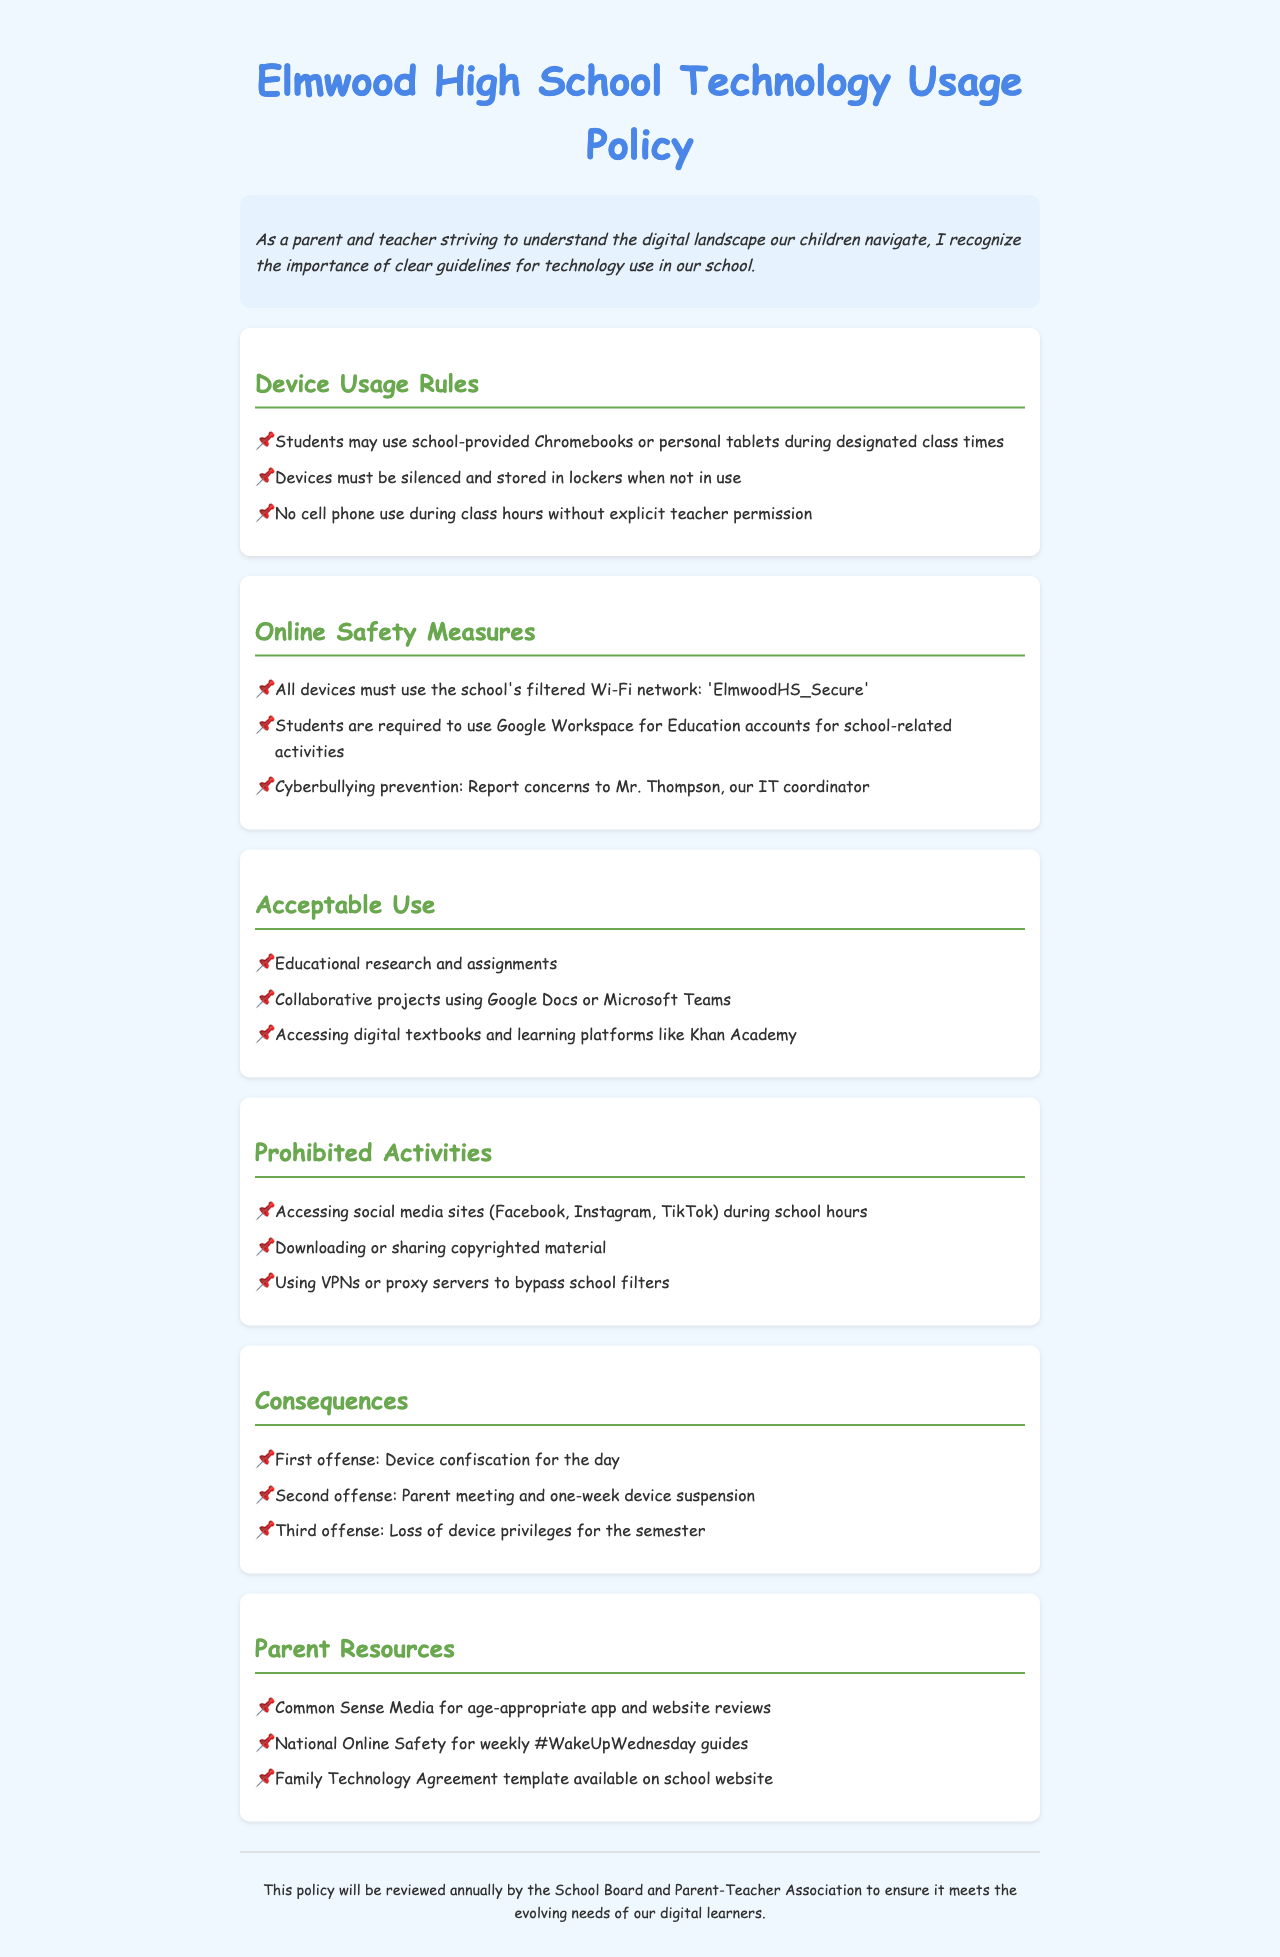What devices can students use during class? The document states that students may use school-provided Chromebooks or personal tablets during designated class times.
Answer: Chromebooks or personal tablets What must students do with their devices when not in use? According to the document, devices must be silenced and stored in lockers when not in use.
Answer: Silenced and stored in lockers How should students connect to the internet? The policy requires all devices to use the school's filtered Wi-Fi network named 'ElmwoodHS_Secure'.
Answer: ElmwoodHS_Secure What action should be taken for cyberbullying concerns? The document indicates that students must report concerns to Mr. Thompson, our IT coordinator.
Answer: Report to Mr. Thompson What is the consequence for a second offense of policy violation? The document outlines that the second offense results in a parent meeting and one-week device suspension.
Answer: Parent meeting and one-week device suspension Is accessing social media allowed during school hours? The policy clearly states that accessing social media sites is prohibited during school hours.
Answer: No What is one of the resources provided for parents regarding online safety? According to the policy document, Common Sense Media is mentioned as a resource for age-appropriate app and website reviews.
Answer: Common Sense Media How often will the technology usage policy be reviewed? The document mentions that this policy will be reviewed annually by the School Board and Parent-Teacher Association.
Answer: Annually What is considered an acceptable use of technology? The document lists educational research and assignments as acceptable use of technology.
Answer: Educational research and assignments 